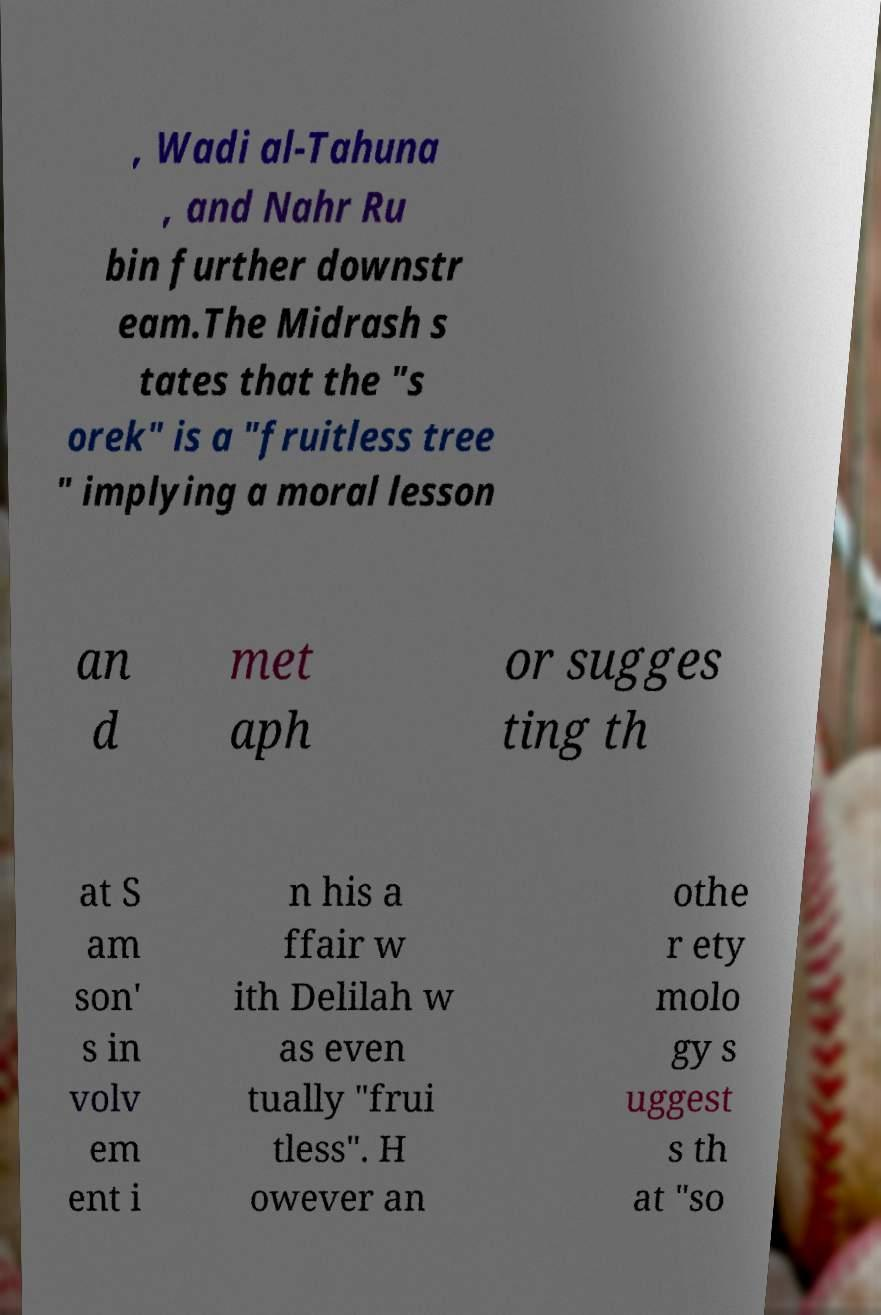There's text embedded in this image that I need extracted. Can you transcribe it verbatim? , Wadi al-Tahuna , and Nahr Ru bin further downstr eam.The Midrash s tates that the "s orek" is a "fruitless tree " implying a moral lesson an d met aph or sugges ting th at S am son' s in volv em ent i n his a ffair w ith Delilah w as even tually "frui tless". H owever an othe r ety molo gy s uggest s th at "so 